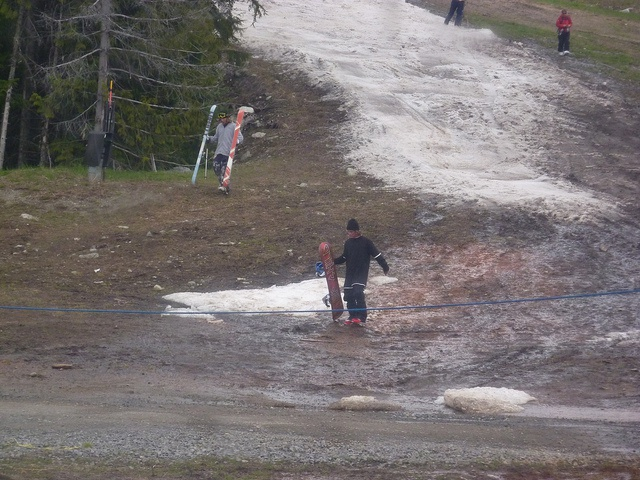Describe the objects in this image and their specific colors. I can see people in darkgreen, black, and gray tones, people in darkgreen, gray, and black tones, snowboard in darkgreen, gray, darkgray, and black tones, skis in darkgreen, darkgray, gray, salmon, and lightgray tones, and people in darkgreen, gray, black, and purple tones in this image. 